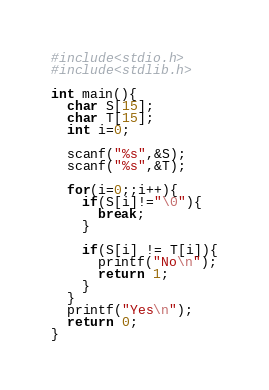Convert code to text. <code><loc_0><loc_0><loc_500><loc_500><_C_>#include<stdio.h>
#include<stdlib.h>

int main(){
  char S[15];
  char T[15];
  int i=0;
  
  scanf("%s",&S);
  scanf("%s",&T);
  
  for(i=0;;i++){
    if(S[i]!="\0"){
      break;
    }
    
    if(S[i] != T[i]){
      printf("No\n");
      return 1;
    }
  }
  printf("Yes\n");
  return 0;
}</code> 